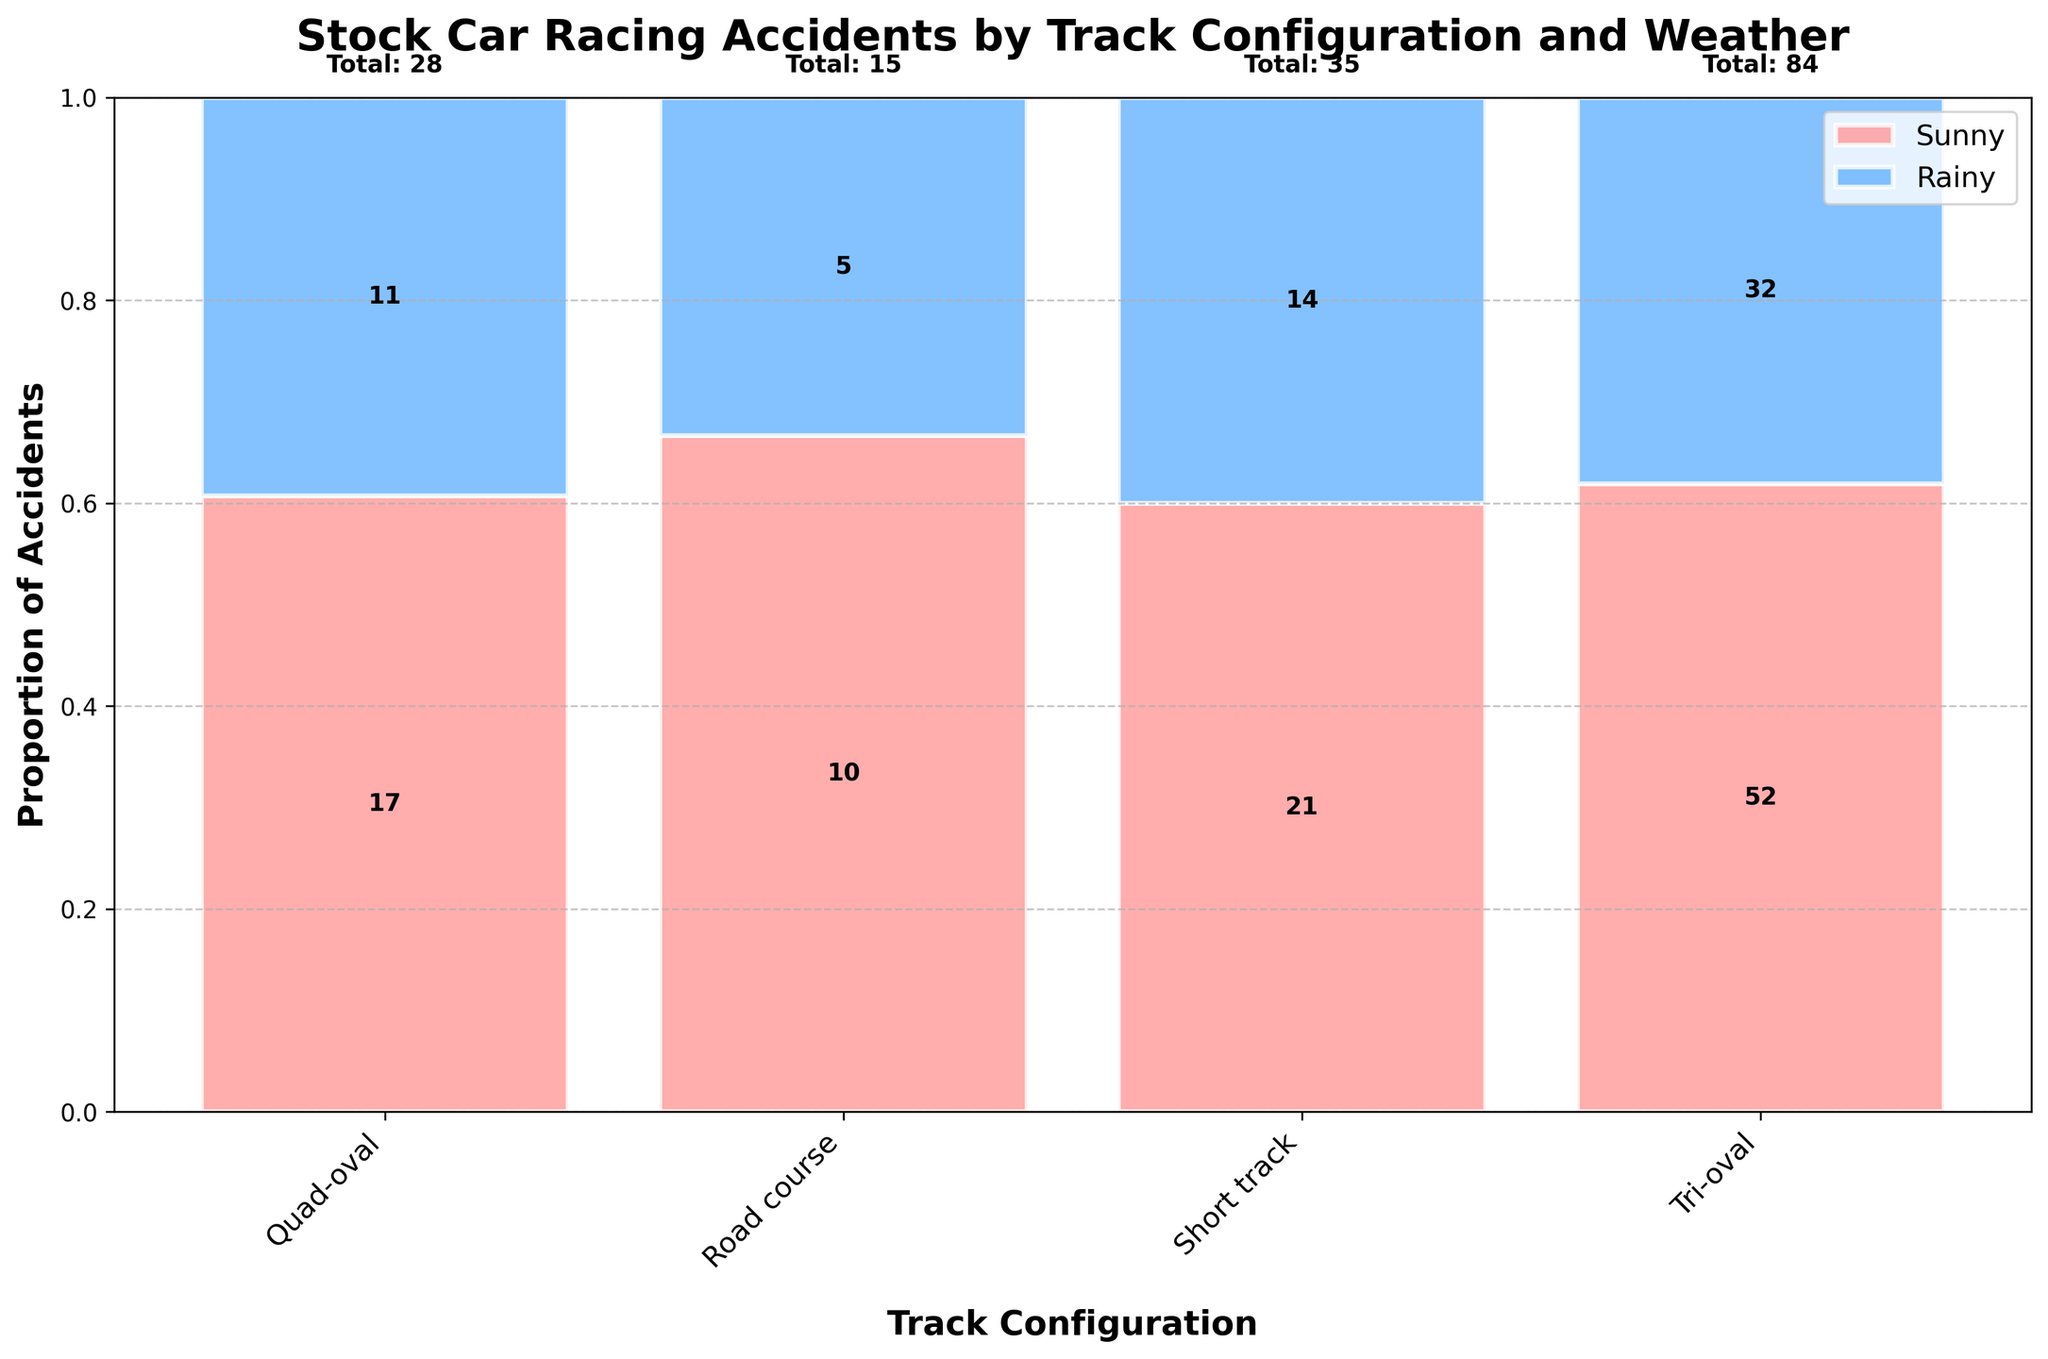What is the title of the figure? The title is typically located at the top of the figure and it provides an overview of what the plot represents. By looking at this area, we can see the text specified as the title.
Answer: Stock Car Racing Accidents by Track Configuration and Weather How many track configurations are shown in the plot? The x-axis represents different track configurations, which can be identified by examining the labels along this axis. Count each label to get the total number.
Answer: 4 Which weather condition has the highest proportion of accidents in the Tri-oval configuration? To find this, we look at the Tri-oval bar segment and compare the heights of the Sunny and Rainy sections. The taller section represents the weather condition with the highest proportion of accidents.
Answer: Rainy How many accidents occurred at Short tracks in total? Total accidents per configuration can be identified from the labels on top of each bar. By looking at the label associated with Short tracks, we sum the figures.
Answer: 35 What is the overall proportion of Sunny weather accidents in the Road course configuration? Each bar segment's height shows the proportion of accidents for that weather condition. For the Road course configuration, we can visually approximate this or read the label inside the Sunny segment.
Answer: 0.33 (approx.) Which configuration has the least total number of accidents? We compare the total values indicated above each bar for all configurations and pick the one with the lowest number.
Answer: Road course Is the number of accidents higher on Sunny or Rainy days for the Quad-oval configuration? By comparing the heights of the Sunny and Rainy segments within the Quad-oval bar, it is evident which is taller, indicating a higher number of accidents.
Answer: Rainy What is the sum of accidents in Rainy conditions across all configurations? Adding the values from the Rainy segments of each bar provides the total number of accidents in Rainy conditions across all configurations.
Answer: 100 How many more accidents occurred under Rainy conditions compared to Sunny conditions in the Tri-oval configuration? Subtract the number of accidents in Sunny conditions from the number in Rainy conditions within the Tri-oval bar for the difference.
Answer: 20 Which track configuration has the highest proportion of Sunny weather accidents? By comparing the heights (or proportions) of the Sunny segments across all configurations, we determine which is the tallest.
Answer: Short track 